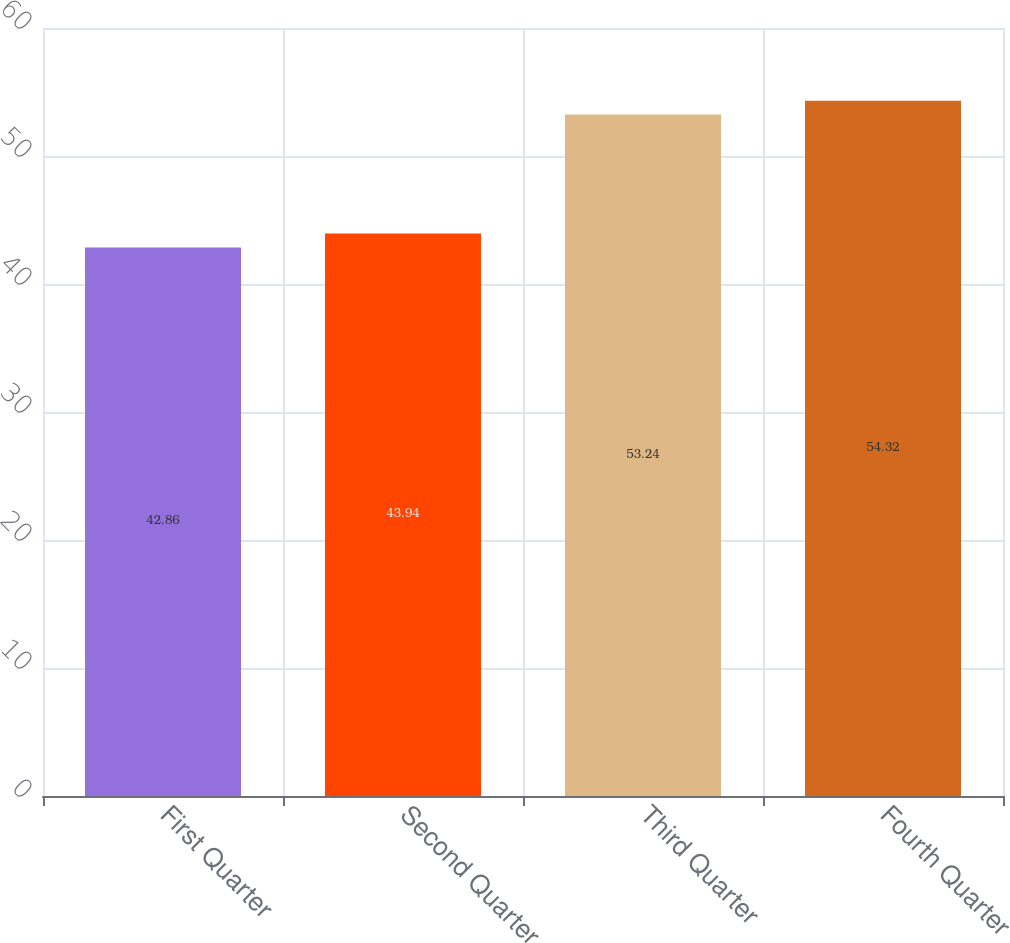Convert chart to OTSL. <chart><loc_0><loc_0><loc_500><loc_500><bar_chart><fcel>First Quarter<fcel>Second Quarter<fcel>Third Quarter<fcel>Fourth Quarter<nl><fcel>42.86<fcel>43.94<fcel>53.24<fcel>54.32<nl></chart> 